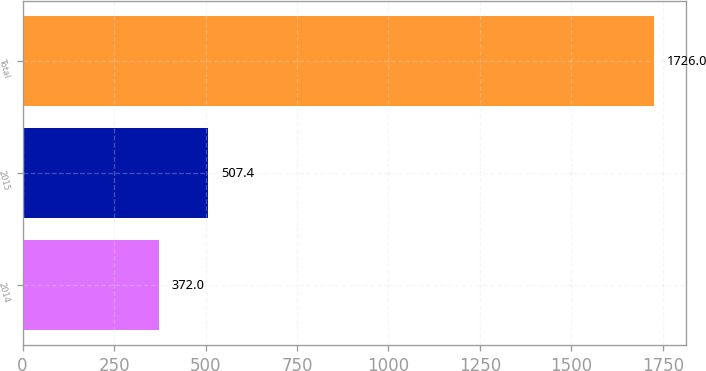Convert chart. <chart><loc_0><loc_0><loc_500><loc_500><bar_chart><fcel>2014<fcel>2015<fcel>Total<nl><fcel>372<fcel>507.4<fcel>1726<nl></chart> 